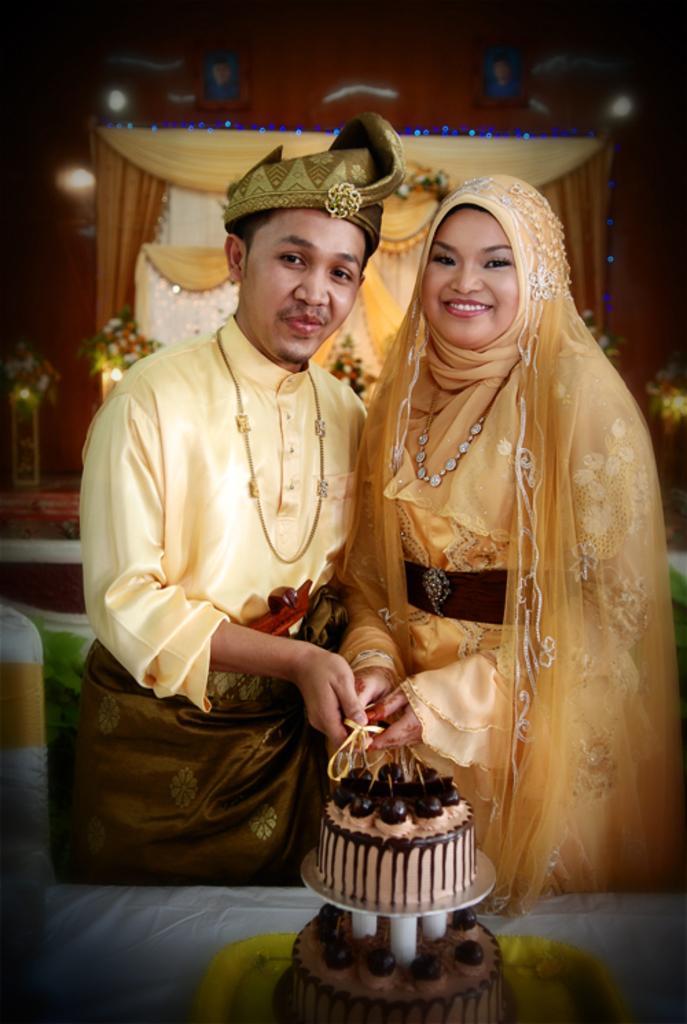How would you summarize this image in a sentence or two? In this image we can see a man and a woman are standing. At the bottom of the image, we can see a cake in a tray. The tray is on the white color surface. In the background, we can see wall, curtains and flowers. It seems like a chair on the left side of the image. 